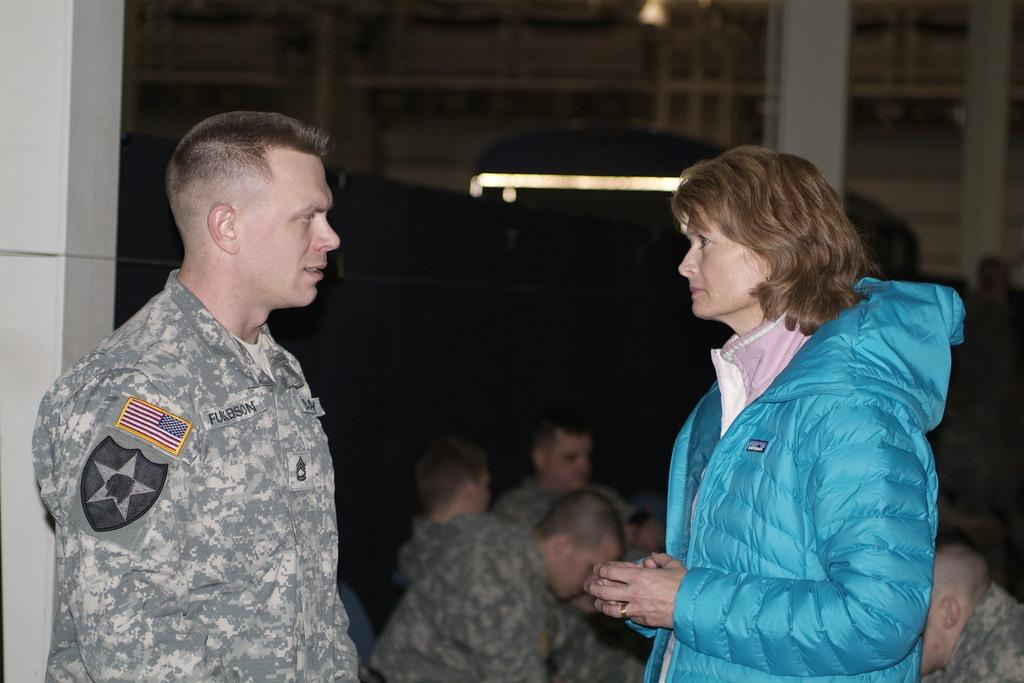What is the occupation of the man on the left side of the image? The man on the left side of the image is dressed in army attire. What is the woman on the right side of the image wearing? The woman on the right side of the image is wearing a blue coat. Can you describe the people sitting in the middle of the image? Unfortunately, the facts provided do not give any information about the people sitting in the middle of the image. What type of drink is being served to the birds in the image? There are no birds or drinks present in the image. 